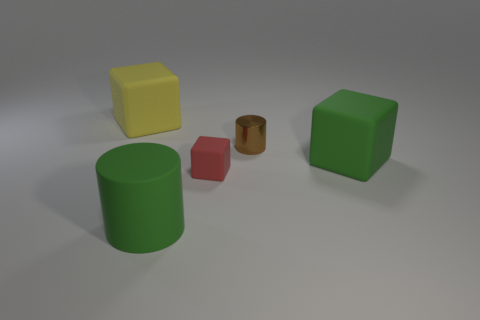Add 1 tiny yellow balls. How many objects exist? 6 Subtract all blocks. How many objects are left? 2 Subtract all large things. Subtract all large cubes. How many objects are left? 0 Add 5 green rubber cylinders. How many green rubber cylinders are left? 6 Add 1 yellow blocks. How many yellow blocks exist? 2 Subtract 1 brown cylinders. How many objects are left? 4 